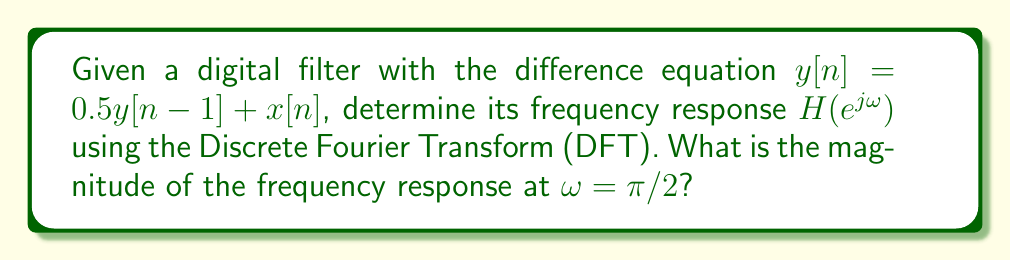Provide a solution to this math problem. To solve this problem, we'll follow these steps:

1) First, we need to determine the transfer function $H(z)$ of the digital filter:
   $$H(z) = \frac{Y(z)}{X(z)} = \frac{1}{1 - 0.5z^{-1}}$$

2) To find the frequency response, we substitute $z = e^{j\omega}$:
   $$H(e^{j\omega}) = \frac{1}{1 - 0.5e^{-j\omega}}$$

3) We can simplify this expression:
   $$H(e^{j\omega}) = \frac{1}{1 - 0.5(\cos\omega - j\sin\omega)}$$

4) Multiply numerator and denominator by the complex conjugate of the denominator:
   $$H(e^{j\omega}) = \frac{1 - 0.5(\cos\omega + j\sin\omega)}{(1 - 0.5\cos\omega)^2 + (0.5\sin\omega)^2}$$

5) The magnitude of the frequency response is:
   $$|H(e^{j\omega})| = \sqrt{\frac{1 + 0.25 - \cos\omega}{1.25 - \cos\omega}}$$

6) For $\omega = \pi/2$:
   $$|H(e^{j\pi/2})| = \sqrt{\frac{1 + 0.25 - \cos(\pi/2)}{1.25 - \cos(\pi/2)}} = \sqrt{\frac{1.25}{1.25}} = 1$$

Therefore, the magnitude of the frequency response at $\omega = \pi/2$ is 1.
Answer: 1 